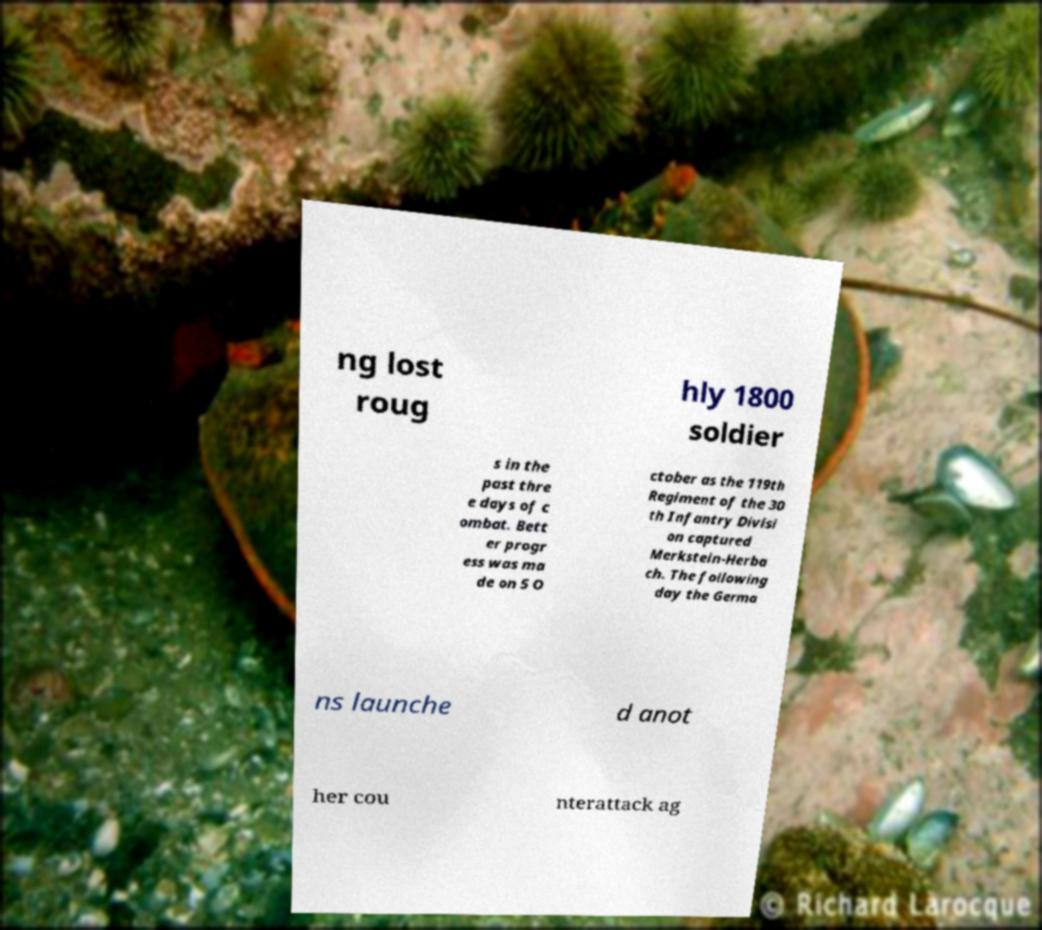Could you assist in decoding the text presented in this image and type it out clearly? ng lost roug hly 1800 soldier s in the past thre e days of c ombat. Bett er progr ess was ma de on 5 O ctober as the 119th Regiment of the 30 th Infantry Divisi on captured Merkstein-Herba ch. The following day the Germa ns launche d anot her cou nterattack ag 